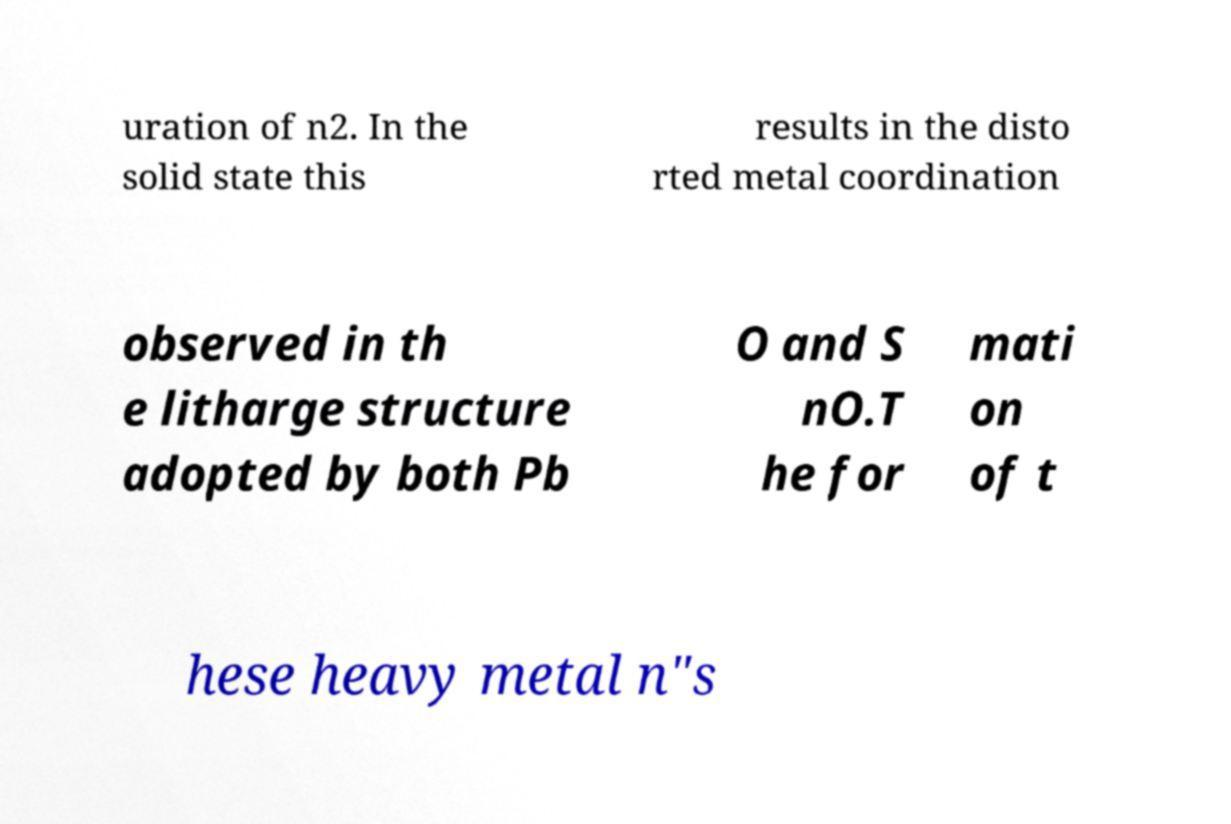For documentation purposes, I need the text within this image transcribed. Could you provide that? uration of n2. In the solid state this results in the disto rted metal coordination observed in th e litharge structure adopted by both Pb O and S nO.T he for mati on of t hese heavy metal n"s 